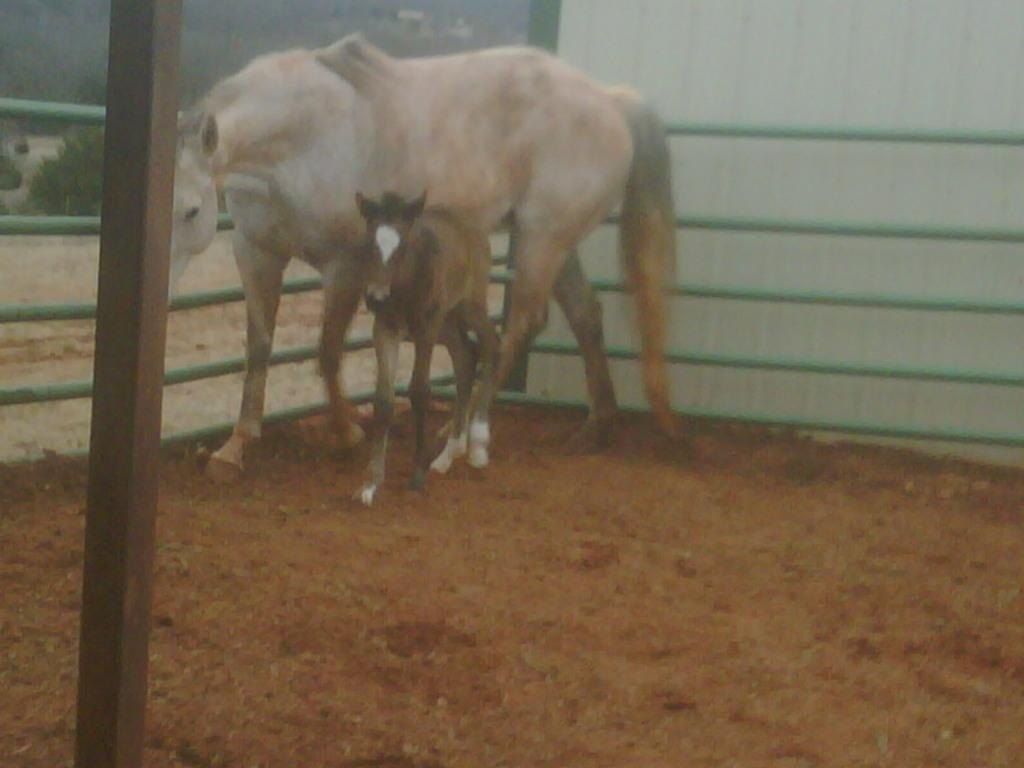What type of animal is present in the image? There is a horse and a baby horse in the image. What are the horses doing in the image? Both horses are standing on the ground. What can be seen in the background of the image? There is fencing in the background of the image. Can you tell me how many coughs the horse makes in the image? There is no indication of coughing in the image, so it cannot be determined. 